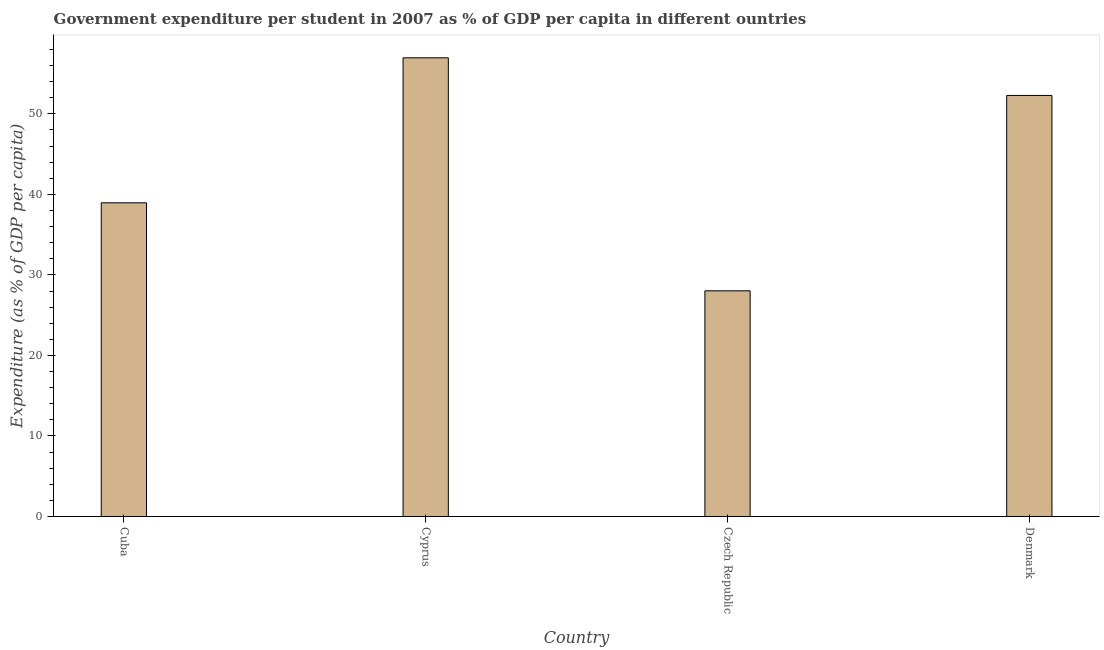Does the graph contain any zero values?
Provide a succinct answer. No. What is the title of the graph?
Your answer should be very brief. Government expenditure per student in 2007 as % of GDP per capita in different ountries. What is the label or title of the X-axis?
Your answer should be very brief. Country. What is the label or title of the Y-axis?
Ensure brevity in your answer.  Expenditure (as % of GDP per capita). What is the government expenditure per student in Cyprus?
Make the answer very short. 56.96. Across all countries, what is the maximum government expenditure per student?
Provide a short and direct response. 56.96. Across all countries, what is the minimum government expenditure per student?
Offer a very short reply. 28.02. In which country was the government expenditure per student maximum?
Your response must be concise. Cyprus. In which country was the government expenditure per student minimum?
Your answer should be compact. Czech Republic. What is the sum of the government expenditure per student?
Your response must be concise. 176.23. What is the difference between the government expenditure per student in Cuba and Denmark?
Provide a succinct answer. -13.33. What is the average government expenditure per student per country?
Give a very brief answer. 44.06. What is the median government expenditure per student?
Keep it short and to the point. 45.62. In how many countries, is the government expenditure per student greater than 32 %?
Your answer should be compact. 3. What is the ratio of the government expenditure per student in Cuba to that in Czech Republic?
Keep it short and to the point. 1.39. Is the government expenditure per student in Cuba less than that in Czech Republic?
Keep it short and to the point. No. What is the difference between the highest and the second highest government expenditure per student?
Your answer should be compact. 4.67. Is the sum of the government expenditure per student in Cuba and Cyprus greater than the maximum government expenditure per student across all countries?
Give a very brief answer. Yes. What is the difference between the highest and the lowest government expenditure per student?
Keep it short and to the point. 28.94. What is the Expenditure (as % of GDP per capita) of Cuba?
Offer a terse response. 38.96. What is the Expenditure (as % of GDP per capita) in Cyprus?
Offer a very short reply. 56.96. What is the Expenditure (as % of GDP per capita) of Czech Republic?
Offer a terse response. 28.02. What is the Expenditure (as % of GDP per capita) of Denmark?
Keep it short and to the point. 52.29. What is the difference between the Expenditure (as % of GDP per capita) in Cuba and Cyprus?
Offer a very short reply. -18.01. What is the difference between the Expenditure (as % of GDP per capita) in Cuba and Czech Republic?
Ensure brevity in your answer.  10.93. What is the difference between the Expenditure (as % of GDP per capita) in Cuba and Denmark?
Keep it short and to the point. -13.33. What is the difference between the Expenditure (as % of GDP per capita) in Cyprus and Czech Republic?
Your answer should be very brief. 28.94. What is the difference between the Expenditure (as % of GDP per capita) in Cyprus and Denmark?
Ensure brevity in your answer.  4.67. What is the difference between the Expenditure (as % of GDP per capita) in Czech Republic and Denmark?
Make the answer very short. -24.26. What is the ratio of the Expenditure (as % of GDP per capita) in Cuba to that in Cyprus?
Your answer should be compact. 0.68. What is the ratio of the Expenditure (as % of GDP per capita) in Cuba to that in Czech Republic?
Provide a succinct answer. 1.39. What is the ratio of the Expenditure (as % of GDP per capita) in Cuba to that in Denmark?
Your answer should be very brief. 0.74. What is the ratio of the Expenditure (as % of GDP per capita) in Cyprus to that in Czech Republic?
Ensure brevity in your answer.  2.03. What is the ratio of the Expenditure (as % of GDP per capita) in Cyprus to that in Denmark?
Ensure brevity in your answer.  1.09. What is the ratio of the Expenditure (as % of GDP per capita) in Czech Republic to that in Denmark?
Your answer should be compact. 0.54. 